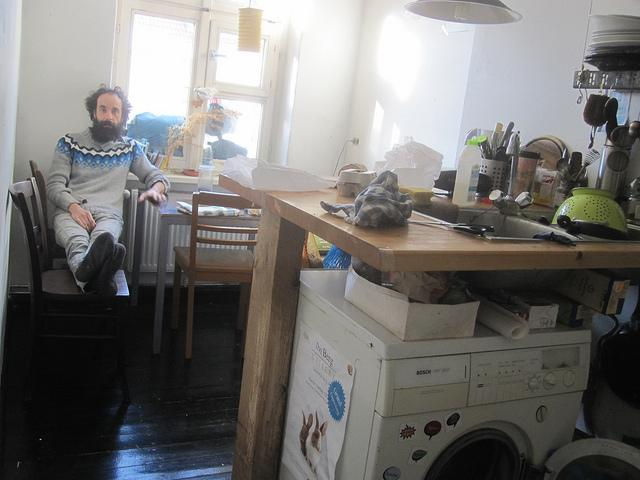What is the green object with holes in it called? colander 